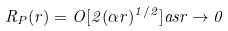Convert formula to latex. <formula><loc_0><loc_0><loc_500><loc_500>R _ { P } ( r ) = O [ 2 ( \alpha r ) ^ { 1 / 2 } ] a s r \rightarrow 0</formula> 